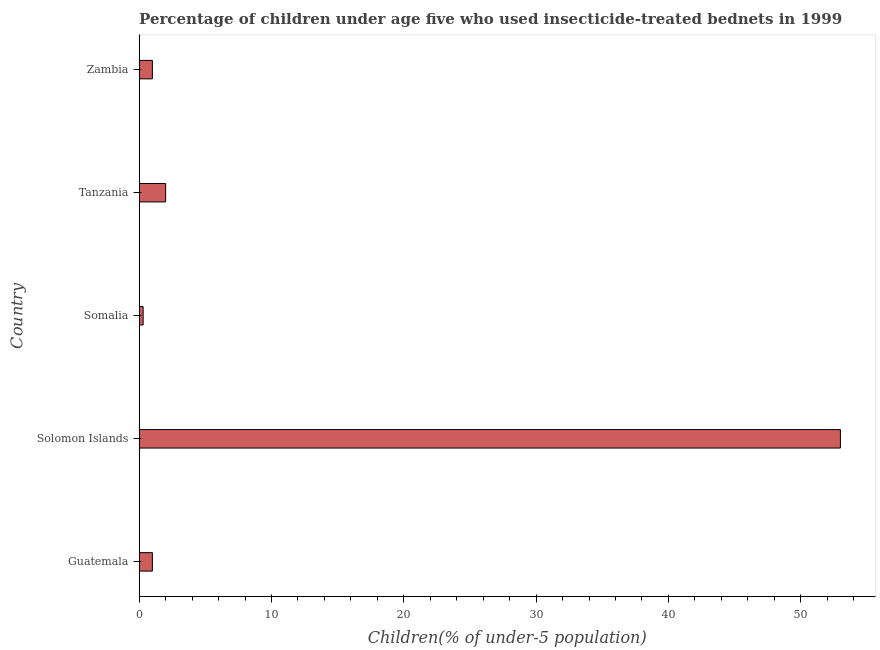Does the graph contain grids?
Your response must be concise. No. What is the title of the graph?
Keep it short and to the point. Percentage of children under age five who used insecticide-treated bednets in 1999. What is the label or title of the X-axis?
Offer a very short reply. Children(% of under-5 population). What is the label or title of the Y-axis?
Ensure brevity in your answer.  Country. What is the percentage of children who use of insecticide-treated bed nets in Zambia?
Make the answer very short. 1. Across all countries, what is the maximum percentage of children who use of insecticide-treated bed nets?
Offer a very short reply. 53. Across all countries, what is the minimum percentage of children who use of insecticide-treated bed nets?
Provide a succinct answer. 0.3. In which country was the percentage of children who use of insecticide-treated bed nets maximum?
Your response must be concise. Solomon Islands. In which country was the percentage of children who use of insecticide-treated bed nets minimum?
Your answer should be very brief. Somalia. What is the sum of the percentage of children who use of insecticide-treated bed nets?
Your answer should be very brief. 57.3. What is the difference between the percentage of children who use of insecticide-treated bed nets in Solomon Islands and Somalia?
Your answer should be very brief. 52.7. What is the average percentage of children who use of insecticide-treated bed nets per country?
Provide a short and direct response. 11.46. Is the difference between the percentage of children who use of insecticide-treated bed nets in Guatemala and Zambia greater than the difference between any two countries?
Make the answer very short. No. Is the sum of the percentage of children who use of insecticide-treated bed nets in Solomon Islands and Zambia greater than the maximum percentage of children who use of insecticide-treated bed nets across all countries?
Provide a succinct answer. Yes. What is the difference between the highest and the lowest percentage of children who use of insecticide-treated bed nets?
Provide a short and direct response. 52.7. In how many countries, is the percentage of children who use of insecticide-treated bed nets greater than the average percentage of children who use of insecticide-treated bed nets taken over all countries?
Your response must be concise. 1. How many countries are there in the graph?
Ensure brevity in your answer.  5. What is the difference between two consecutive major ticks on the X-axis?
Your response must be concise. 10. Are the values on the major ticks of X-axis written in scientific E-notation?
Offer a terse response. No. What is the Children(% of under-5 population) in Solomon Islands?
Your answer should be very brief. 53. What is the Children(% of under-5 population) of Somalia?
Provide a short and direct response. 0.3. What is the Children(% of under-5 population) in Zambia?
Offer a very short reply. 1. What is the difference between the Children(% of under-5 population) in Guatemala and Solomon Islands?
Offer a terse response. -52. What is the difference between the Children(% of under-5 population) in Guatemala and Somalia?
Offer a very short reply. 0.7. What is the difference between the Children(% of under-5 population) in Guatemala and Tanzania?
Provide a succinct answer. -1. What is the difference between the Children(% of under-5 population) in Solomon Islands and Somalia?
Provide a succinct answer. 52.7. What is the difference between the Children(% of under-5 population) in Solomon Islands and Zambia?
Offer a terse response. 52. What is the difference between the Children(% of under-5 population) in Somalia and Tanzania?
Your response must be concise. -1.7. What is the difference between the Children(% of under-5 population) in Somalia and Zambia?
Provide a succinct answer. -0.7. What is the difference between the Children(% of under-5 population) in Tanzania and Zambia?
Offer a terse response. 1. What is the ratio of the Children(% of under-5 population) in Guatemala to that in Solomon Islands?
Give a very brief answer. 0.02. What is the ratio of the Children(% of under-5 population) in Guatemala to that in Somalia?
Offer a terse response. 3.33. What is the ratio of the Children(% of under-5 population) in Solomon Islands to that in Somalia?
Give a very brief answer. 176.67. What is the ratio of the Children(% of under-5 population) in Tanzania to that in Zambia?
Your answer should be very brief. 2. 